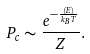Convert formula to latex. <formula><loc_0><loc_0><loc_500><loc_500>P _ { c } \sim \frac { e ^ { - \frac { \langle E \rangle } { k _ { B } T } } } { Z } .</formula> 